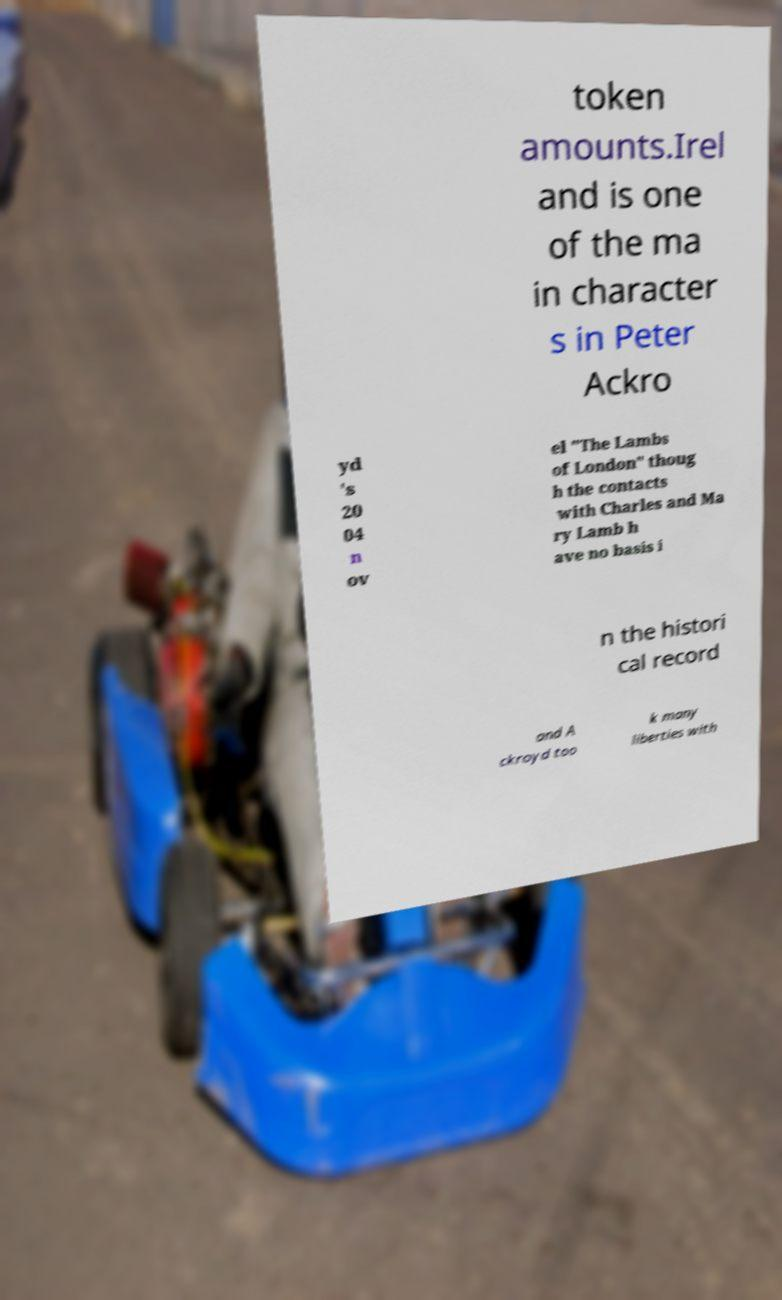Please read and relay the text visible in this image. What does it say? token amounts.Irel and is one of the ma in character s in Peter Ackro yd 's 20 04 n ov el "The Lambs of London" thoug h the contacts with Charles and Ma ry Lamb h ave no basis i n the histori cal record and A ckroyd too k many liberties with 